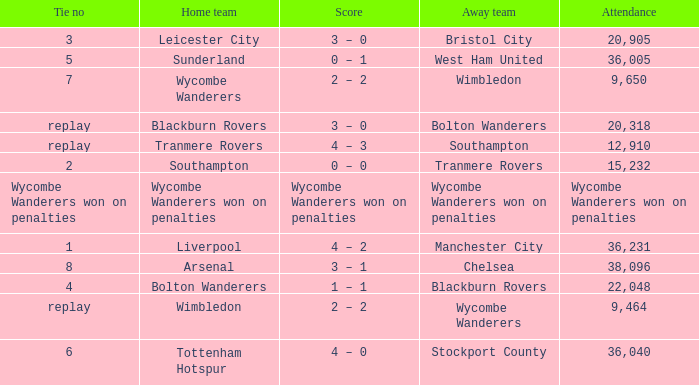What was the score for the match where the home team was Leicester City? 3 – 0. 